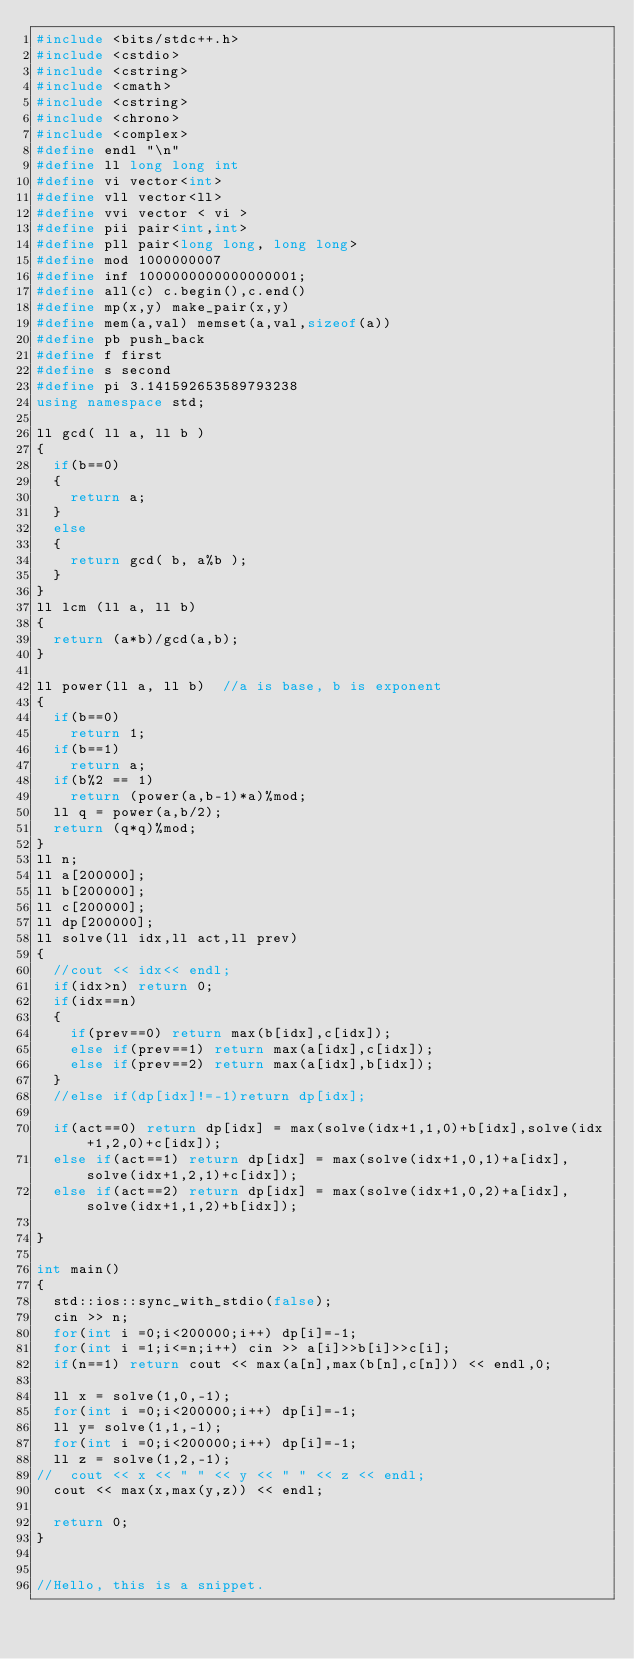Convert code to text. <code><loc_0><loc_0><loc_500><loc_500><_C++_>#include <bits/stdc++.h>
#include <cstdio>
#include <cstring>
#include <cmath>
#include <cstring>
#include <chrono>
#include <complex>
#define endl "\n"
#define ll long long int
#define vi vector<int>
#define vll vector<ll>
#define vvi vector < vi >
#define pii pair<int,int>
#define pll pair<long long, long long>
#define mod 1000000007
#define inf 1000000000000000001;
#define all(c) c.begin(),c.end()
#define mp(x,y) make_pair(x,y)
#define mem(a,val) memset(a,val,sizeof(a))
#define pb push_back
#define f first
#define s second
#define pi 3.141592653589793238
using namespace std;

ll gcd( ll a, ll b )
{
	if(b==0)
	{
		return a;
	}
	else
	{
		return gcd( b, a%b );
	}
}
ll lcm (ll a, ll b)
{
	return (a*b)/gcd(a,b);
}

ll power(ll a, ll b)	//a is base, b is exponent
{
	if(b==0)
		return 1;
	if(b==1)
		return a;
	if(b%2 == 1)
		return (power(a,b-1)*a)%mod;
	ll q = power(a,b/2);
	return (q*q)%mod;
}
ll n;
ll a[200000];
ll b[200000];
ll c[200000];
ll dp[200000];
ll solve(ll idx,ll act,ll prev)
{
	//cout << idx<< endl;
	if(idx>n) return 0;
	if(idx==n) 
	{
		if(prev==0) return max(b[idx],c[idx]);
		else if(prev==1) return max(a[idx],c[idx]);
		else if(prev==2) return max(a[idx],b[idx]);
	}
	//else if(dp[idx]!=-1)return dp[idx];
	
	if(act==0) return dp[idx] = max(solve(idx+1,1,0)+b[idx],solve(idx+1,2,0)+c[idx]);
	else if(act==1) return dp[idx] = max(solve(idx+1,0,1)+a[idx],solve(idx+1,2,1)+c[idx]);
	else if(act==2) return dp[idx] = max(solve(idx+1,0,2)+a[idx],solve(idx+1,1,2)+b[idx]);
	
}

int main()
{
	std::ios::sync_with_stdio(false);
	cin >> n;
	for(int i =0;i<200000;i++) dp[i]=-1;
	for(int i =1;i<=n;i++) cin >> a[i]>>b[i]>>c[i];		
	if(n==1) return cout << max(a[n],max(b[n],c[n])) << endl,0;

	ll x = solve(1,0,-1);
	for(int i =0;i<200000;i++) dp[i]=-1;
	ll y= solve(1,1,-1);
	for(int i =0;i<200000;i++) dp[i]=-1;
	ll z = solve(1,2,-1);
//	cout << x << " " << y << " " << z << endl;
	cout << max(x,max(y,z)) << endl;

	return 0;
}


//Hello, this is a snippet.
</code> 